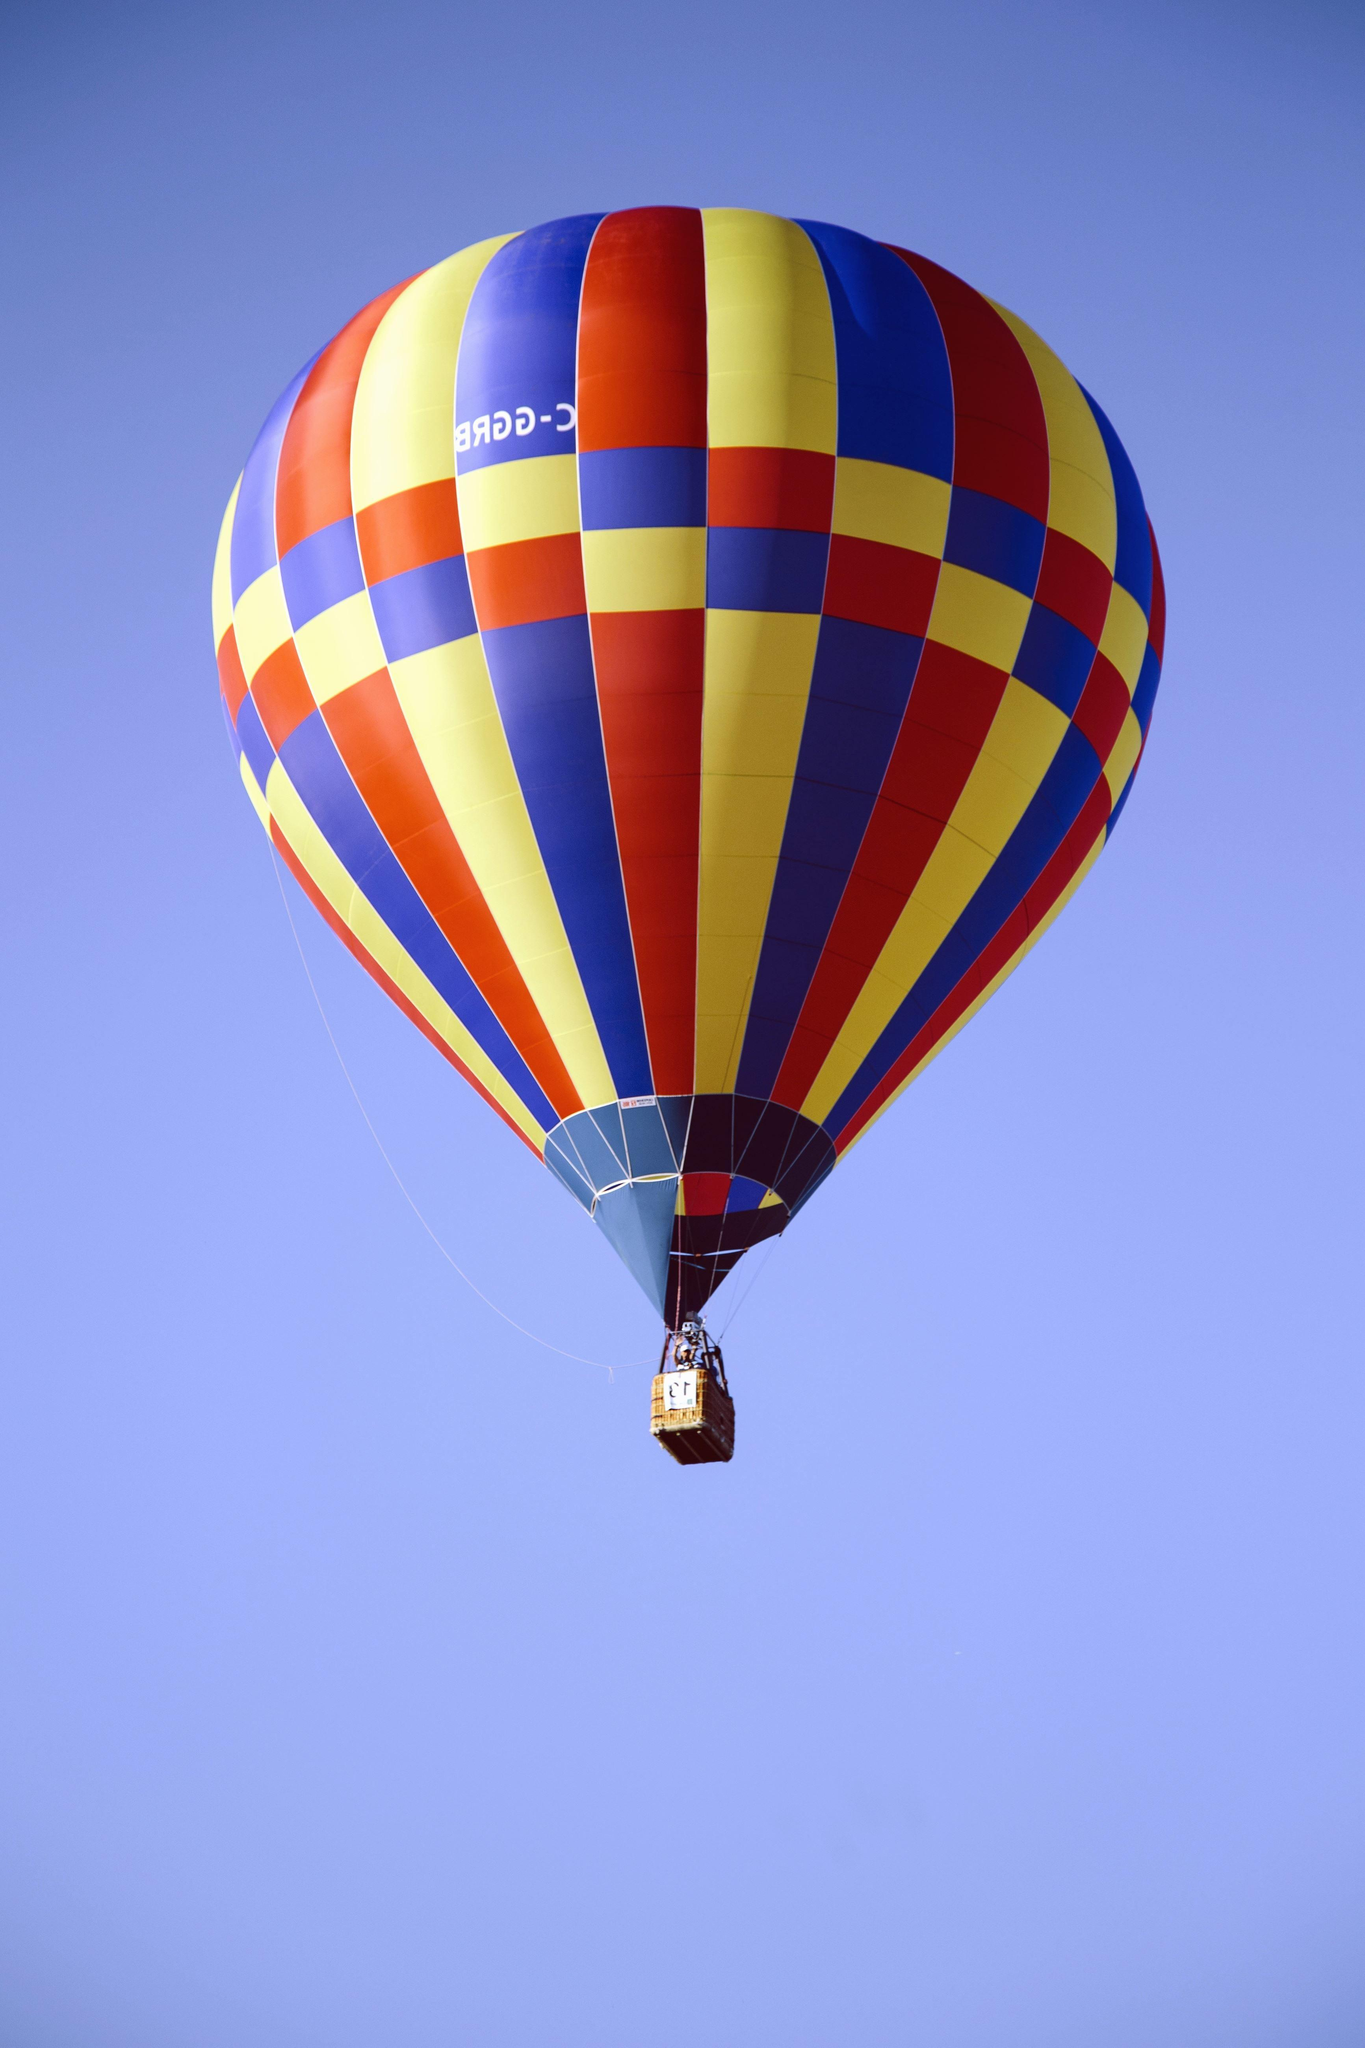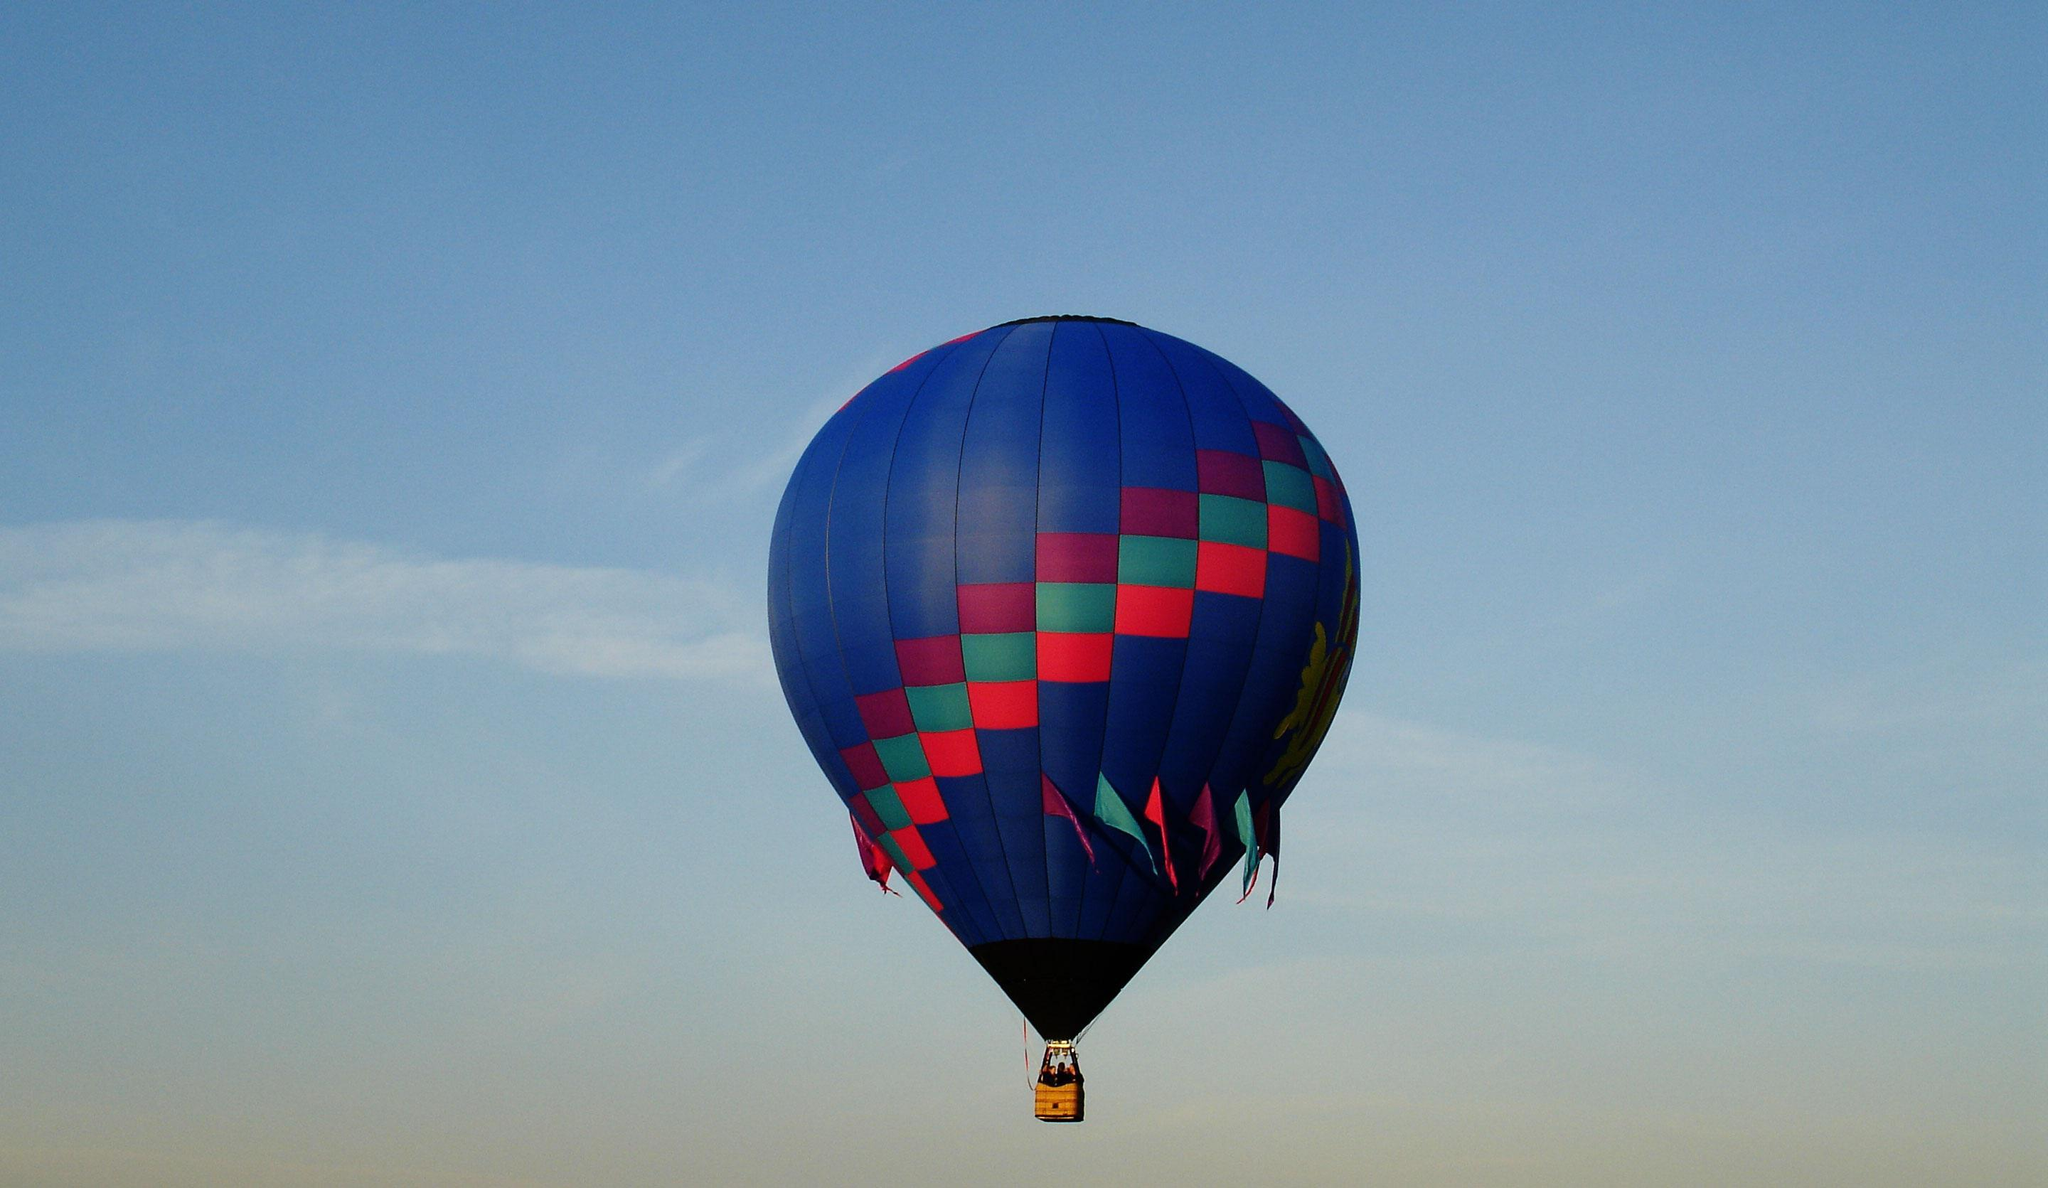The first image is the image on the left, the second image is the image on the right. Analyze the images presented: Is the assertion "All images show more than six balloons in the air." valid? Answer yes or no. No. 